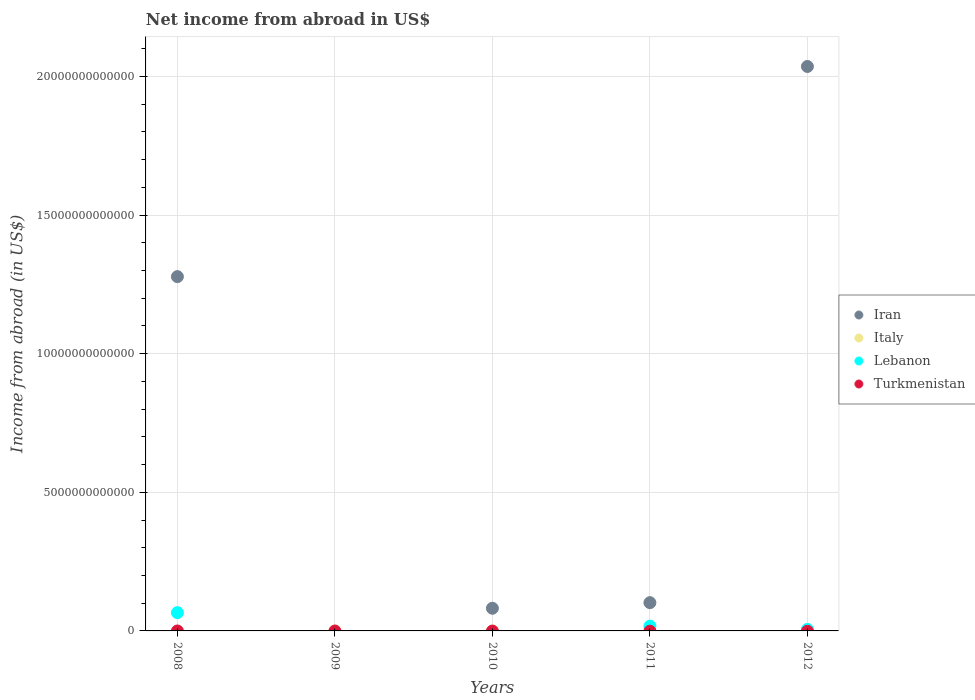How many different coloured dotlines are there?
Make the answer very short. 2. What is the net income from abroad in Iran in 2011?
Your answer should be very brief. 1.02e+12. Across all years, what is the maximum net income from abroad in Iran?
Keep it short and to the point. 2.04e+13. Across all years, what is the minimum net income from abroad in Iran?
Make the answer very short. 0. What is the difference between the net income from abroad in Iran in 2008 and that in 2011?
Make the answer very short. 1.18e+13. What is the average net income from abroad in Italy per year?
Provide a short and direct response. 0. In the year 2011, what is the difference between the net income from abroad in Lebanon and net income from abroad in Iran?
Provide a short and direct response. -8.47e+11. What is the ratio of the net income from abroad in Iran in 2008 to that in 2010?
Your answer should be compact. 15.63. What is the difference between the highest and the second highest net income from abroad in Iran?
Give a very brief answer. 7.58e+12. What is the difference between the highest and the lowest net income from abroad in Lebanon?
Provide a succinct answer. 6.59e+11. In how many years, is the net income from abroad in Italy greater than the average net income from abroad in Italy taken over all years?
Your response must be concise. 0. Is the sum of the net income from abroad in Iran in 2010 and 2011 greater than the maximum net income from abroad in Lebanon across all years?
Keep it short and to the point. Yes. Is it the case that in every year, the sum of the net income from abroad in Turkmenistan and net income from abroad in Lebanon  is greater than the sum of net income from abroad in Iran and net income from abroad in Italy?
Offer a very short reply. No. Is the net income from abroad in Italy strictly greater than the net income from abroad in Turkmenistan over the years?
Your response must be concise. No. Is the net income from abroad in Lebanon strictly less than the net income from abroad in Iran over the years?
Your answer should be compact. No. How many years are there in the graph?
Give a very brief answer. 5. What is the difference between two consecutive major ticks on the Y-axis?
Offer a very short reply. 5.00e+12. Does the graph contain any zero values?
Offer a terse response. Yes. How are the legend labels stacked?
Your response must be concise. Vertical. What is the title of the graph?
Make the answer very short. Net income from abroad in US$. What is the label or title of the X-axis?
Offer a very short reply. Years. What is the label or title of the Y-axis?
Your response must be concise. Income from abroad (in US$). What is the Income from abroad (in US$) in Iran in 2008?
Ensure brevity in your answer.  1.28e+13. What is the Income from abroad (in US$) in Italy in 2008?
Provide a succinct answer. 0. What is the Income from abroad (in US$) of Lebanon in 2008?
Give a very brief answer. 6.59e+11. What is the Income from abroad (in US$) in Turkmenistan in 2008?
Offer a very short reply. 0. What is the Income from abroad (in US$) in Iran in 2009?
Provide a short and direct response. 0. What is the Income from abroad (in US$) in Italy in 2009?
Provide a short and direct response. 0. What is the Income from abroad (in US$) of Turkmenistan in 2009?
Provide a succinct answer. 0. What is the Income from abroad (in US$) of Iran in 2010?
Give a very brief answer. 8.18e+11. What is the Income from abroad (in US$) in Italy in 2010?
Your answer should be compact. 0. What is the Income from abroad (in US$) in Lebanon in 2010?
Provide a short and direct response. 0. What is the Income from abroad (in US$) of Iran in 2011?
Give a very brief answer. 1.02e+12. What is the Income from abroad (in US$) in Italy in 2011?
Ensure brevity in your answer.  0. What is the Income from abroad (in US$) of Lebanon in 2011?
Your response must be concise. 1.73e+11. What is the Income from abroad (in US$) in Iran in 2012?
Your answer should be compact. 2.04e+13. What is the Income from abroad (in US$) in Italy in 2012?
Your response must be concise. 0. What is the Income from abroad (in US$) in Lebanon in 2012?
Offer a very short reply. 5.55e+1. What is the Income from abroad (in US$) in Turkmenistan in 2012?
Provide a short and direct response. 0. Across all years, what is the maximum Income from abroad (in US$) of Iran?
Keep it short and to the point. 2.04e+13. Across all years, what is the maximum Income from abroad (in US$) in Lebanon?
Provide a short and direct response. 6.59e+11. Across all years, what is the minimum Income from abroad (in US$) of Iran?
Provide a succinct answer. 0. Across all years, what is the minimum Income from abroad (in US$) in Lebanon?
Make the answer very short. 0. What is the total Income from abroad (in US$) of Iran in the graph?
Keep it short and to the point. 3.50e+13. What is the total Income from abroad (in US$) in Italy in the graph?
Ensure brevity in your answer.  0. What is the total Income from abroad (in US$) in Lebanon in the graph?
Ensure brevity in your answer.  8.87e+11. What is the difference between the Income from abroad (in US$) in Iran in 2008 and that in 2010?
Offer a very short reply. 1.20e+13. What is the difference between the Income from abroad (in US$) in Iran in 2008 and that in 2011?
Keep it short and to the point. 1.18e+13. What is the difference between the Income from abroad (in US$) in Lebanon in 2008 and that in 2011?
Ensure brevity in your answer.  4.86e+11. What is the difference between the Income from abroad (in US$) of Iran in 2008 and that in 2012?
Ensure brevity in your answer.  -7.58e+12. What is the difference between the Income from abroad (in US$) of Lebanon in 2008 and that in 2012?
Offer a terse response. 6.04e+11. What is the difference between the Income from abroad (in US$) of Iran in 2010 and that in 2011?
Provide a succinct answer. -2.02e+11. What is the difference between the Income from abroad (in US$) of Iran in 2010 and that in 2012?
Your answer should be very brief. -1.95e+13. What is the difference between the Income from abroad (in US$) of Iran in 2011 and that in 2012?
Your answer should be very brief. -1.93e+13. What is the difference between the Income from abroad (in US$) of Lebanon in 2011 and that in 2012?
Provide a succinct answer. 1.17e+11. What is the difference between the Income from abroad (in US$) in Iran in 2008 and the Income from abroad (in US$) in Lebanon in 2011?
Ensure brevity in your answer.  1.26e+13. What is the difference between the Income from abroad (in US$) in Iran in 2008 and the Income from abroad (in US$) in Lebanon in 2012?
Offer a very short reply. 1.27e+13. What is the difference between the Income from abroad (in US$) of Iran in 2010 and the Income from abroad (in US$) of Lebanon in 2011?
Provide a short and direct response. 6.45e+11. What is the difference between the Income from abroad (in US$) in Iran in 2010 and the Income from abroad (in US$) in Lebanon in 2012?
Provide a succinct answer. 7.62e+11. What is the difference between the Income from abroad (in US$) of Iran in 2011 and the Income from abroad (in US$) of Lebanon in 2012?
Your answer should be compact. 9.64e+11. What is the average Income from abroad (in US$) in Iran per year?
Offer a terse response. 7.00e+12. What is the average Income from abroad (in US$) in Lebanon per year?
Offer a terse response. 1.77e+11. What is the average Income from abroad (in US$) in Turkmenistan per year?
Your answer should be compact. 0. In the year 2008, what is the difference between the Income from abroad (in US$) in Iran and Income from abroad (in US$) in Lebanon?
Your answer should be very brief. 1.21e+13. In the year 2011, what is the difference between the Income from abroad (in US$) of Iran and Income from abroad (in US$) of Lebanon?
Keep it short and to the point. 8.47e+11. In the year 2012, what is the difference between the Income from abroad (in US$) in Iran and Income from abroad (in US$) in Lebanon?
Offer a terse response. 2.03e+13. What is the ratio of the Income from abroad (in US$) in Iran in 2008 to that in 2010?
Offer a terse response. 15.63. What is the ratio of the Income from abroad (in US$) in Iran in 2008 to that in 2011?
Ensure brevity in your answer.  12.54. What is the ratio of the Income from abroad (in US$) in Lebanon in 2008 to that in 2011?
Make the answer very short. 3.81. What is the ratio of the Income from abroad (in US$) of Iran in 2008 to that in 2012?
Your answer should be compact. 0.63. What is the ratio of the Income from abroad (in US$) in Lebanon in 2008 to that in 2012?
Your response must be concise. 11.87. What is the ratio of the Income from abroad (in US$) of Iran in 2010 to that in 2011?
Offer a terse response. 0.8. What is the ratio of the Income from abroad (in US$) in Iran in 2010 to that in 2012?
Ensure brevity in your answer.  0.04. What is the ratio of the Income from abroad (in US$) of Iran in 2011 to that in 2012?
Provide a succinct answer. 0.05. What is the ratio of the Income from abroad (in US$) in Lebanon in 2011 to that in 2012?
Offer a terse response. 3.11. What is the difference between the highest and the second highest Income from abroad (in US$) of Iran?
Provide a succinct answer. 7.58e+12. What is the difference between the highest and the second highest Income from abroad (in US$) of Lebanon?
Your answer should be compact. 4.86e+11. What is the difference between the highest and the lowest Income from abroad (in US$) of Iran?
Offer a terse response. 2.04e+13. What is the difference between the highest and the lowest Income from abroad (in US$) of Lebanon?
Your answer should be very brief. 6.59e+11. 